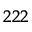<formula> <loc_0><loc_0><loc_500><loc_500>{ } ^ { 2 2 2 }</formula> 